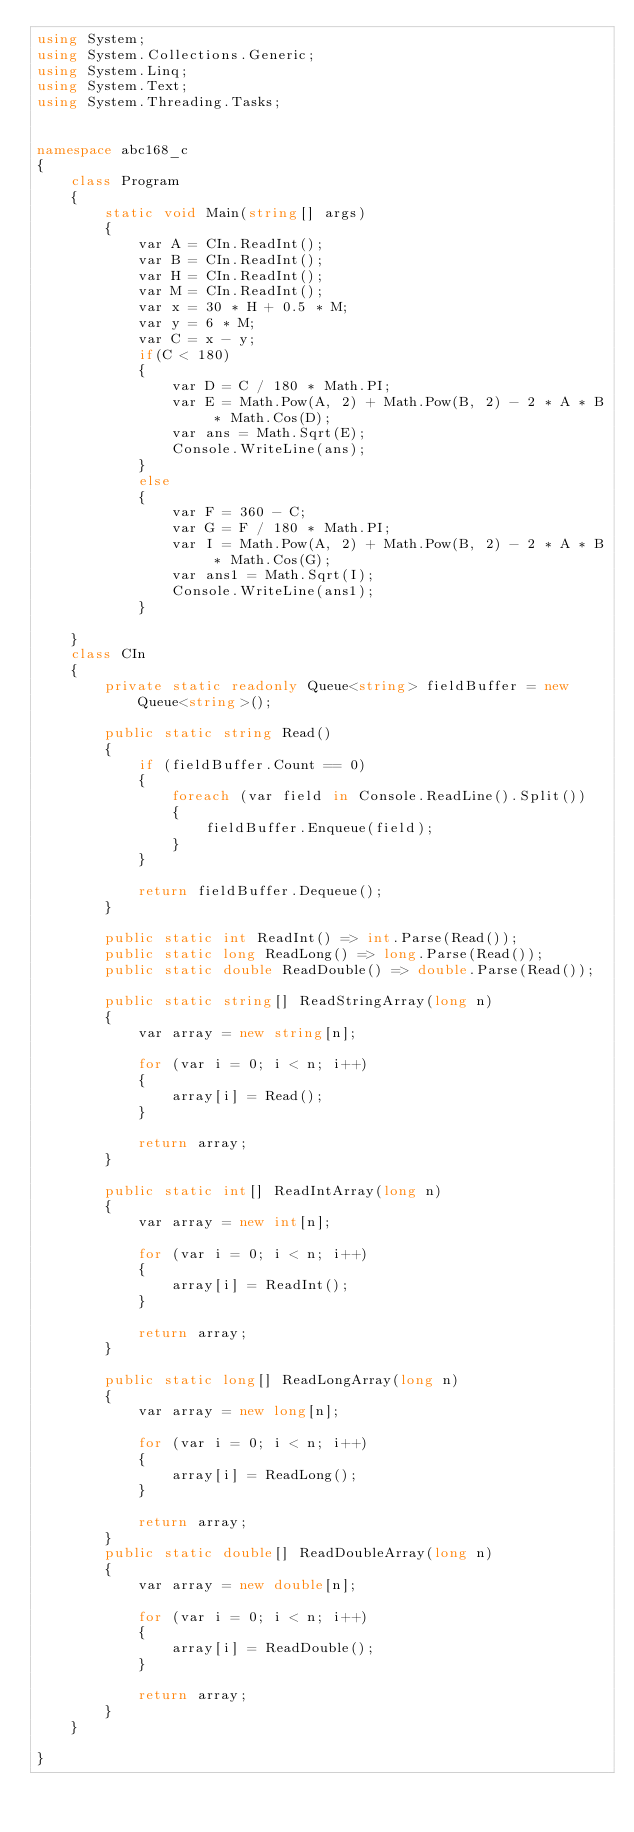<code> <loc_0><loc_0><loc_500><loc_500><_C#_>using System;
using System.Collections.Generic;
using System.Linq;
using System.Text;
using System.Threading.Tasks;


namespace abc168_c
{
    class Program
    {
        static void Main(string[] args)
        {
            var A = CIn.ReadInt();
            var B = CIn.ReadInt();
            var H = CIn.ReadInt();
            var M = CIn.ReadInt();
            var x = 30 * H + 0.5 * M;
            var y = 6 * M;
            var C = x - y;
            if(C < 180)
            {
                var D = C / 180 * Math.PI;
                var E = Math.Pow(A, 2) + Math.Pow(B, 2) - 2 * A * B * Math.Cos(D);
                var ans = Math.Sqrt(E);
                Console.WriteLine(ans);
            }
            else
            {
                var F = 360 - C;
                var G = F / 180 * Math.PI;
                var I = Math.Pow(A, 2) + Math.Pow(B, 2) - 2 * A * B * Math.Cos(G);
                var ans1 = Math.Sqrt(I);
                Console.WriteLine(ans1);
            }
            
    }
    class CIn
    {
        private static readonly Queue<string> fieldBuffer = new Queue<string>();

        public static string Read()
        {
            if (fieldBuffer.Count == 0)
            {
                foreach (var field in Console.ReadLine().Split())
                {
                    fieldBuffer.Enqueue(field);
                }
            }

            return fieldBuffer.Dequeue();
        }

        public static int ReadInt() => int.Parse(Read());
        public static long ReadLong() => long.Parse(Read());
        public static double ReadDouble() => double.Parse(Read());

        public static string[] ReadStringArray(long n)
        {
            var array = new string[n];

            for (var i = 0; i < n; i++)
            {
                array[i] = Read();
            }

            return array;
        }

        public static int[] ReadIntArray(long n)
        {
            var array = new int[n];

            for (var i = 0; i < n; i++)
            {
                array[i] = ReadInt();
            }

            return array;
        }

        public static long[] ReadLongArray(long n)
        {
            var array = new long[n];

            for (var i = 0; i < n; i++)
            {
                array[i] = ReadLong();
            }

            return array;
        }
        public static double[] ReadDoubleArray(long n)
        {
            var array = new double[n];

            for (var i = 0; i < n; i++)
            {
                array[i] = ReadDouble();
            }

            return array;
        }
    }

}
</code> 